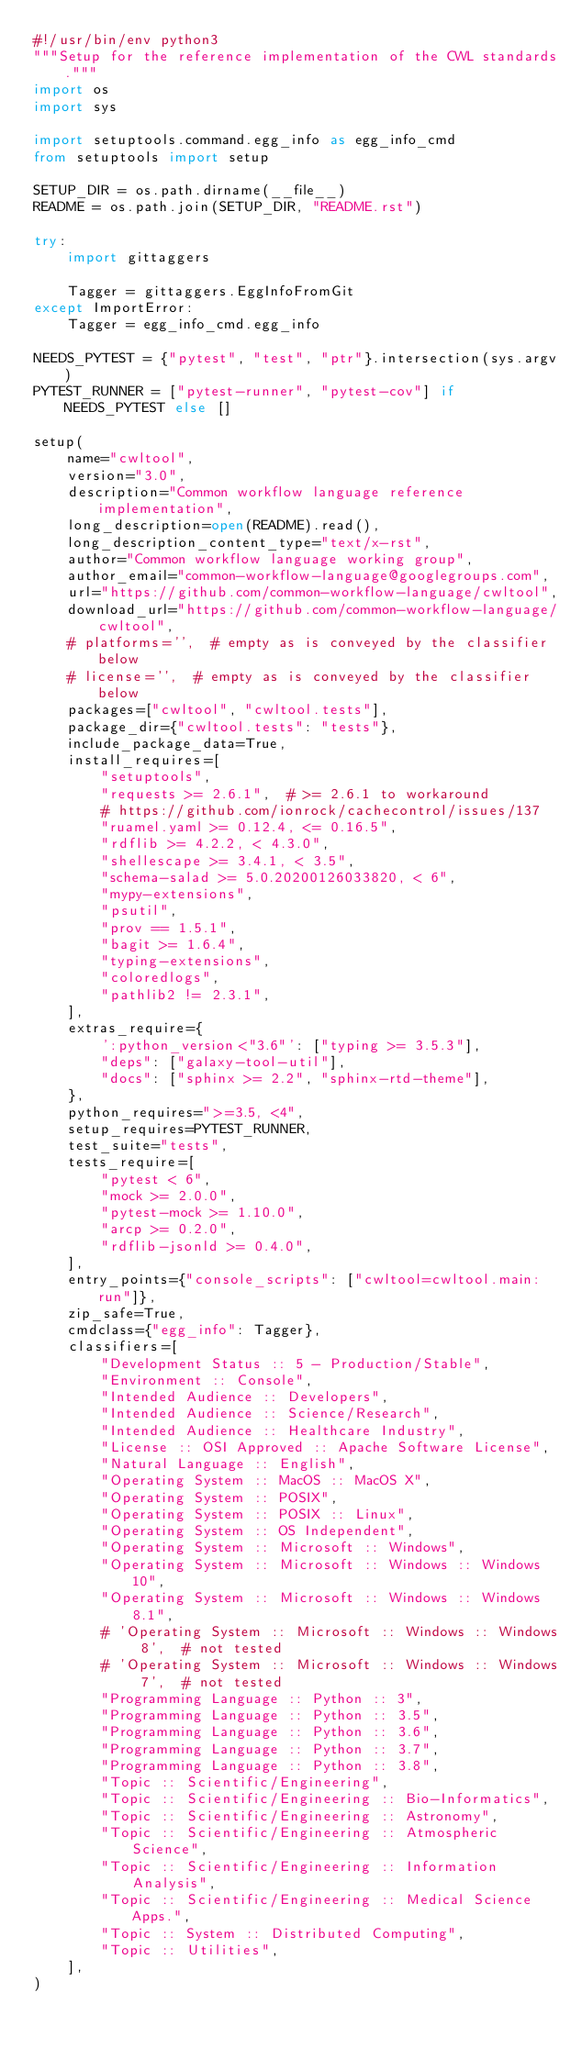Convert code to text. <code><loc_0><loc_0><loc_500><loc_500><_Python_>#!/usr/bin/env python3
"""Setup for the reference implementation of the CWL standards."""
import os
import sys

import setuptools.command.egg_info as egg_info_cmd
from setuptools import setup

SETUP_DIR = os.path.dirname(__file__)
README = os.path.join(SETUP_DIR, "README.rst")

try:
    import gittaggers

    Tagger = gittaggers.EggInfoFromGit
except ImportError:
    Tagger = egg_info_cmd.egg_info

NEEDS_PYTEST = {"pytest", "test", "ptr"}.intersection(sys.argv)
PYTEST_RUNNER = ["pytest-runner", "pytest-cov"] if NEEDS_PYTEST else []

setup(
    name="cwltool",
    version="3.0",
    description="Common workflow language reference implementation",
    long_description=open(README).read(),
    long_description_content_type="text/x-rst",
    author="Common workflow language working group",
    author_email="common-workflow-language@googlegroups.com",
    url="https://github.com/common-workflow-language/cwltool",
    download_url="https://github.com/common-workflow-language/cwltool",
    # platforms='',  # empty as is conveyed by the classifier below
    # license='',  # empty as is conveyed by the classifier below
    packages=["cwltool", "cwltool.tests"],
    package_dir={"cwltool.tests": "tests"},
    include_package_data=True,
    install_requires=[
        "setuptools",
        "requests >= 2.6.1",  # >= 2.6.1 to workaround
        # https://github.com/ionrock/cachecontrol/issues/137
        "ruamel.yaml >= 0.12.4, <= 0.16.5",
        "rdflib >= 4.2.2, < 4.3.0",
        "shellescape >= 3.4.1, < 3.5",
        "schema-salad >= 5.0.20200126033820, < 6",
        "mypy-extensions",
        "psutil",
        "prov == 1.5.1",
        "bagit >= 1.6.4",
        "typing-extensions",
        "coloredlogs",
        "pathlib2 != 2.3.1",
    ],
    extras_require={
        ':python_version<"3.6"': ["typing >= 3.5.3"],
        "deps": ["galaxy-tool-util"],
        "docs": ["sphinx >= 2.2", "sphinx-rtd-theme"],
    },
    python_requires=">=3.5, <4",
    setup_requires=PYTEST_RUNNER,
    test_suite="tests",
    tests_require=[
        "pytest < 6",
        "mock >= 2.0.0",
        "pytest-mock >= 1.10.0",
        "arcp >= 0.2.0",
        "rdflib-jsonld >= 0.4.0",
    ],
    entry_points={"console_scripts": ["cwltool=cwltool.main:run"]},
    zip_safe=True,
    cmdclass={"egg_info": Tagger},
    classifiers=[
        "Development Status :: 5 - Production/Stable",
        "Environment :: Console",
        "Intended Audience :: Developers",
        "Intended Audience :: Science/Research",
        "Intended Audience :: Healthcare Industry",
        "License :: OSI Approved :: Apache Software License",
        "Natural Language :: English",
        "Operating System :: MacOS :: MacOS X",
        "Operating System :: POSIX",
        "Operating System :: POSIX :: Linux",
        "Operating System :: OS Independent",
        "Operating System :: Microsoft :: Windows",
        "Operating System :: Microsoft :: Windows :: Windows 10",
        "Operating System :: Microsoft :: Windows :: Windows 8.1",
        # 'Operating System :: Microsoft :: Windows :: Windows 8',  # not tested
        # 'Operating System :: Microsoft :: Windows :: Windows 7',  # not tested
        "Programming Language :: Python :: 3",
        "Programming Language :: Python :: 3.5",
        "Programming Language :: Python :: 3.6",
        "Programming Language :: Python :: 3.7",
        "Programming Language :: Python :: 3.8",
        "Topic :: Scientific/Engineering",
        "Topic :: Scientific/Engineering :: Bio-Informatics",
        "Topic :: Scientific/Engineering :: Astronomy",
        "Topic :: Scientific/Engineering :: Atmospheric Science",
        "Topic :: Scientific/Engineering :: Information Analysis",
        "Topic :: Scientific/Engineering :: Medical Science Apps.",
        "Topic :: System :: Distributed Computing",
        "Topic :: Utilities",
    ],
)
</code> 